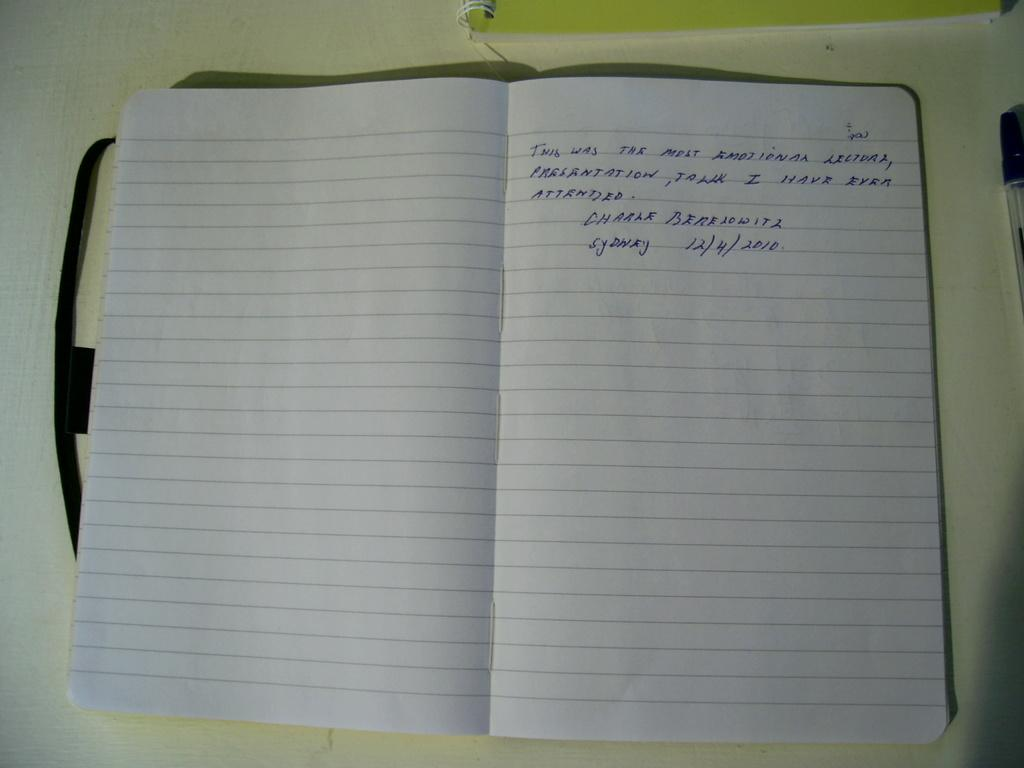<image>
Provide a brief description of the given image. a notebook that is open and written on with sydney on it 